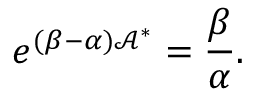<formula> <loc_0><loc_0><loc_500><loc_500>e ^ { ( \beta - \alpha ) \mathcal { A } ^ { \ast } } = \frac { \beta } { \alpha } .</formula> 